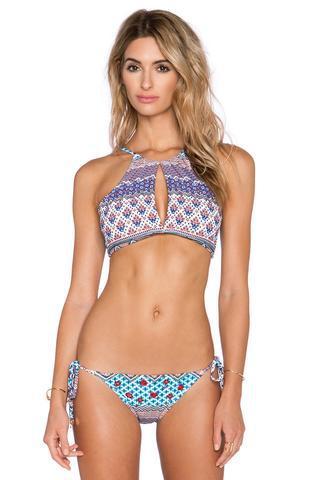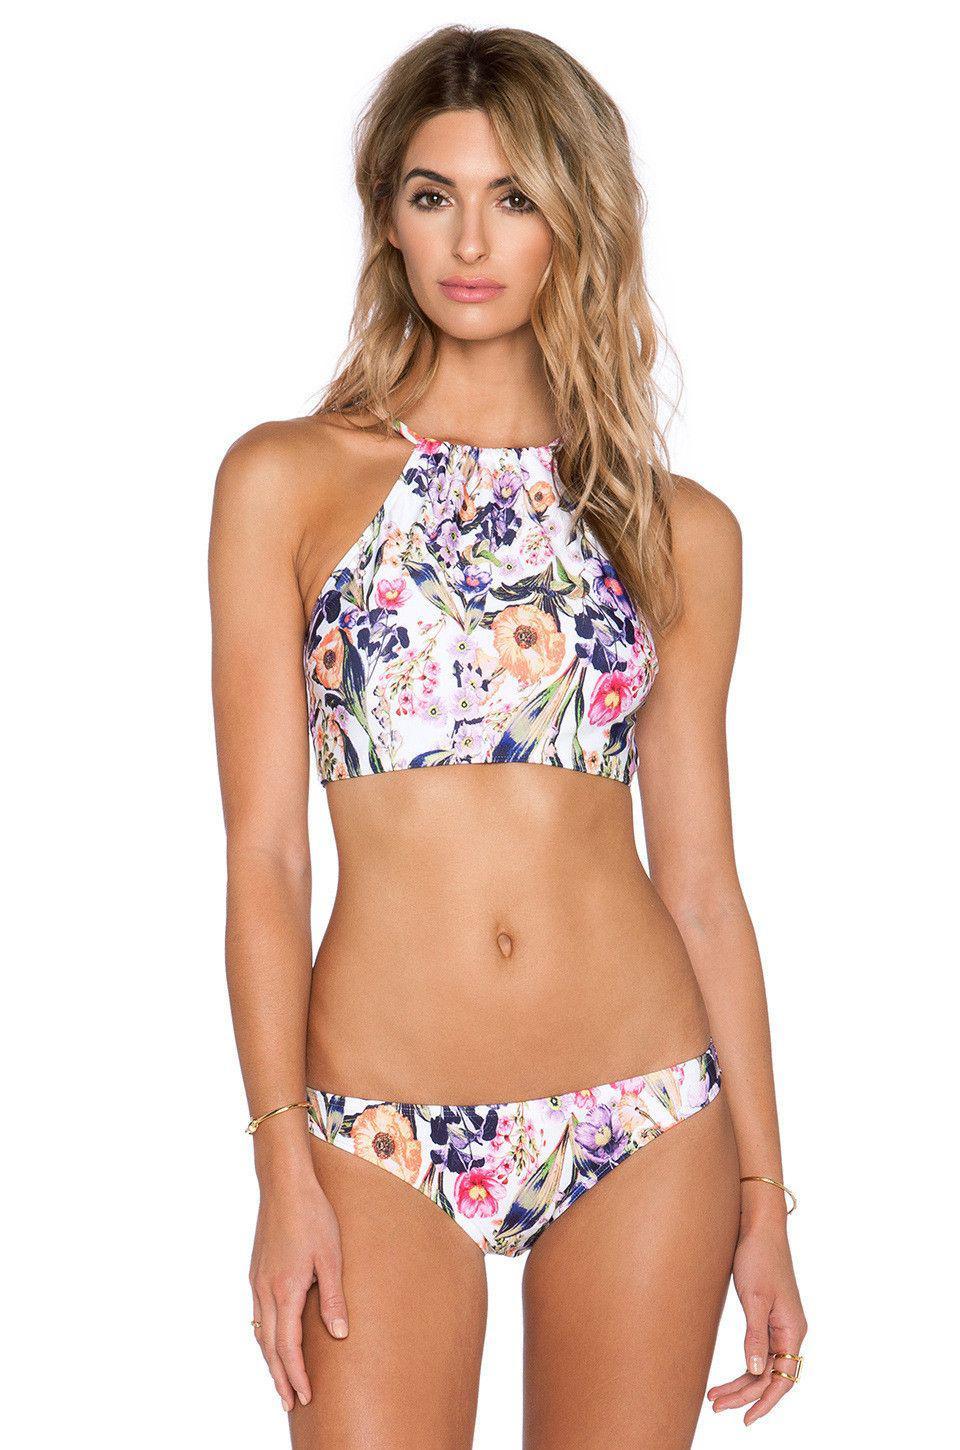The first image is the image on the left, the second image is the image on the right. Evaluate the accuracy of this statement regarding the images: "The model in one of the images does not have her right arm hanging by her side.". Is it true? Answer yes or no. No. 